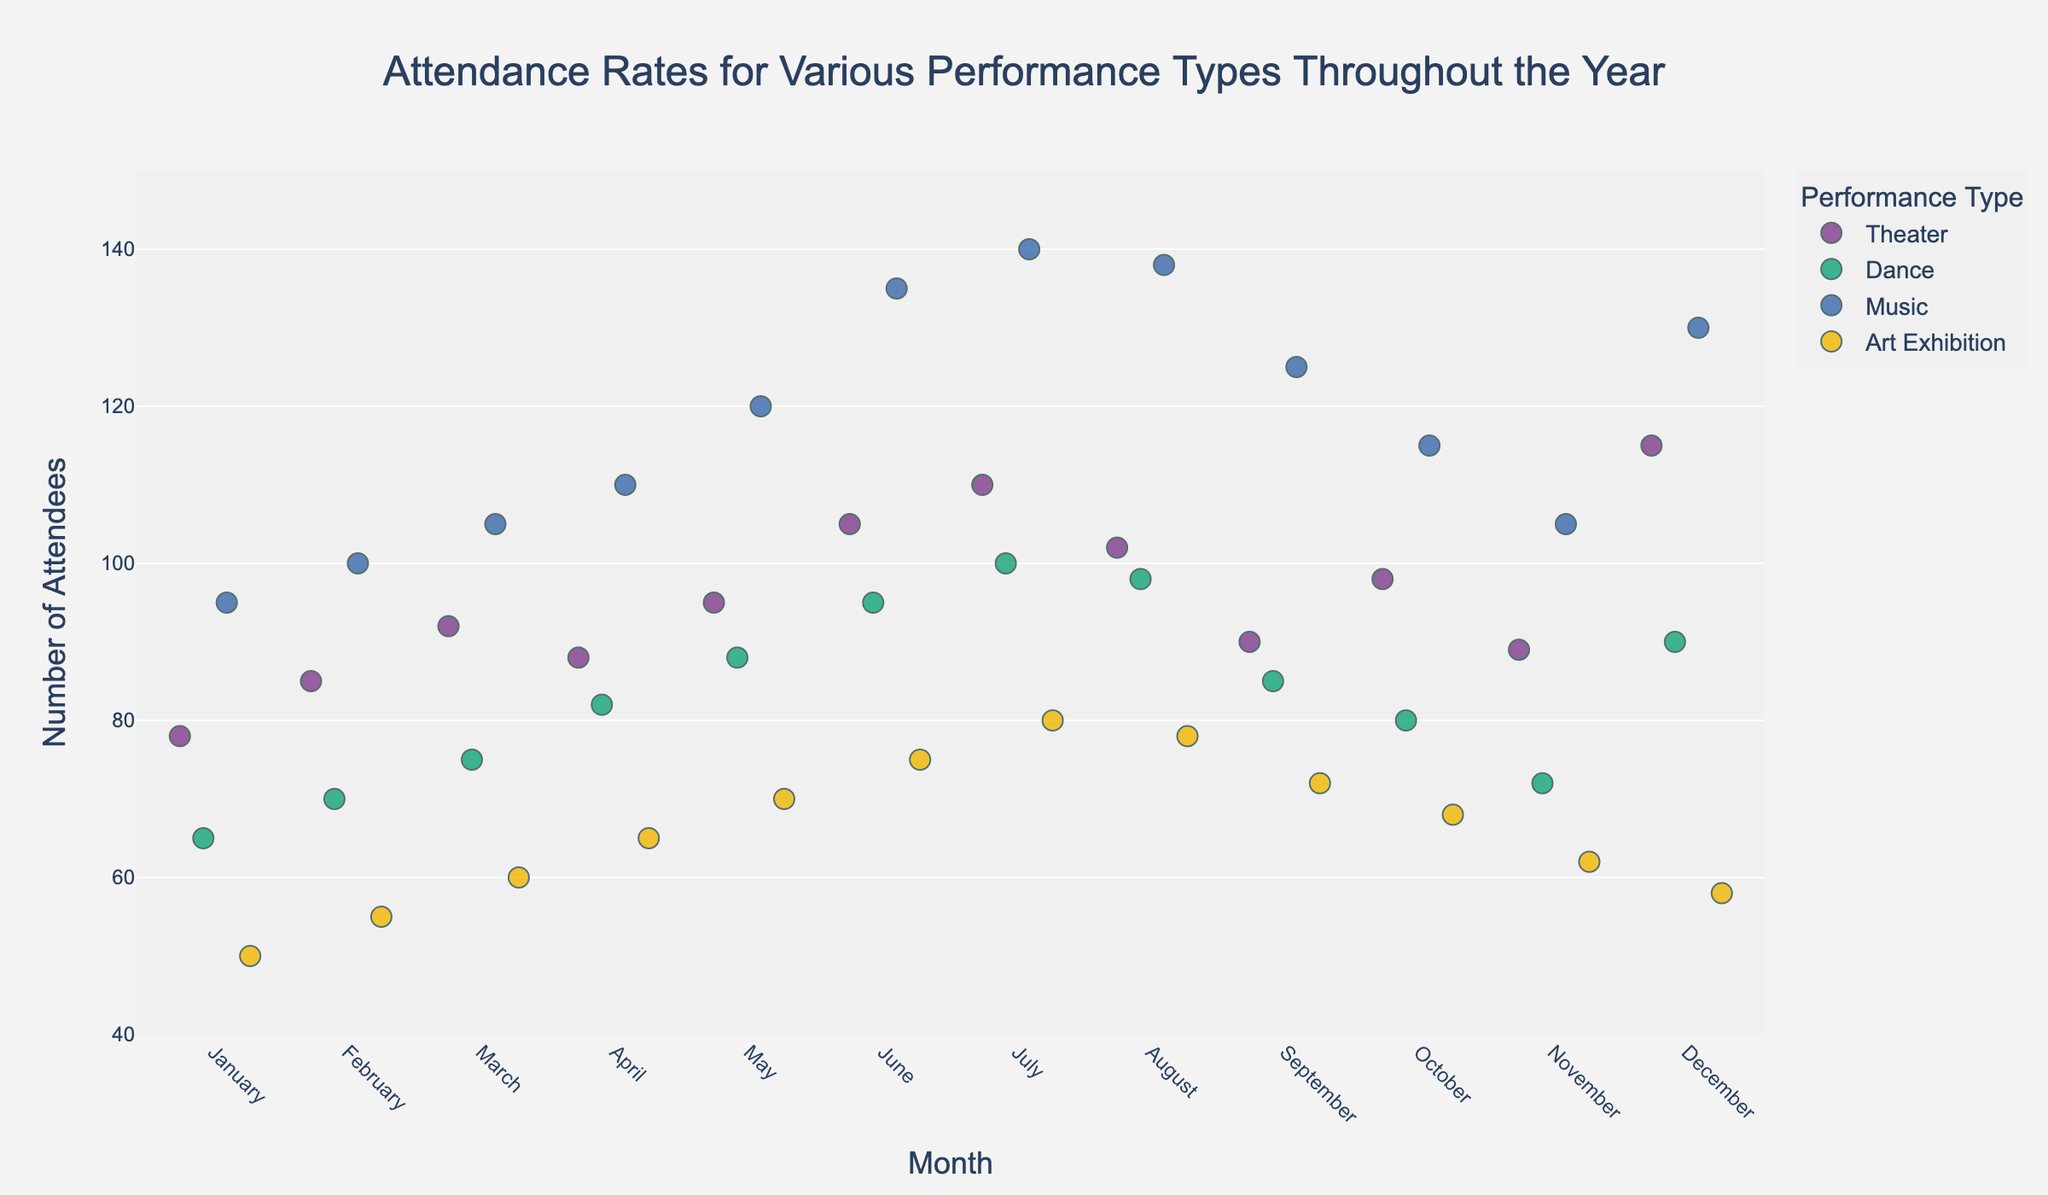What month has the maximum attendance for Theater performances? To answer this, look at the highest point for Theater on the y-axis. December has the highest attendance at 115.
Answer: December Which performance type had the lowest attendance in October? Check the y-axis values for all performance types in October. Art Exhibition has the lowest attendance with a value of 68.
Answer: Art Exhibition What is the average attendance for Dance performances from January to June? Sum up the Dance attendance from January to June (65 + 70 + 75 + 82 + 88 + 95) and divide by the number of months (6). The average is (475 / 6) ≈ 79.17.
Answer: 79.17 Compare the attendance in May for Music and Theater performances. Which has higher attendance? Look at the data points for Music and Theater in May on the y-axis. Music has an attendance of 120, whereas Theater has an attendance of 95. Thus, Music has higher attendance.
Answer: Music Do Theater performances have generally increasing or decreasing attendance over the year? Observe the trend of Theater data points from January to December. The overall trend shows an increase in attendance over the months.
Answer: Increasing How much more was the attendance for Dance in December compared to November? Take the attendance value for Dance in December (90) and subtract the November value (72). The difference is (90 - 72) = 18.
Answer: 18 What is the range of attendance for Art Exhibition performances throughout the year? Identify the minimum and maximum attendance values for Art Exhibition. The minimum is 50 (January), and the maximum is 80 (July). So, the range is (80 - 50) = 30.
Answer: 30 Which performance type has the most consistent attendance throughout the year? Examine the spread of attendance points for each performance type. Art Exhibition has the most consistent (least variation) attendance, as the points are closely packed between 50 and 80.
Answer: Art Exhibition In which quarter of the year does Music have the highest average attendance? Calculate the average attendance for each quarter: Q1 (95, 100, 105), Q2 (110, 120, 135), Q3 (140, 138, 125), Q4 (115, 105, 130). Q3 has the highest average with (140 + 138 + 125) / 3 ≈ 134.33.
Answer: Q3 List the months where Dance has an attendance lower than 80. Find Dance attendance values from the strip plot that are less than 80. These values occur in January (65), February (70), March (75), October (80), and November (72).
Answer: January, February, March, October, November 